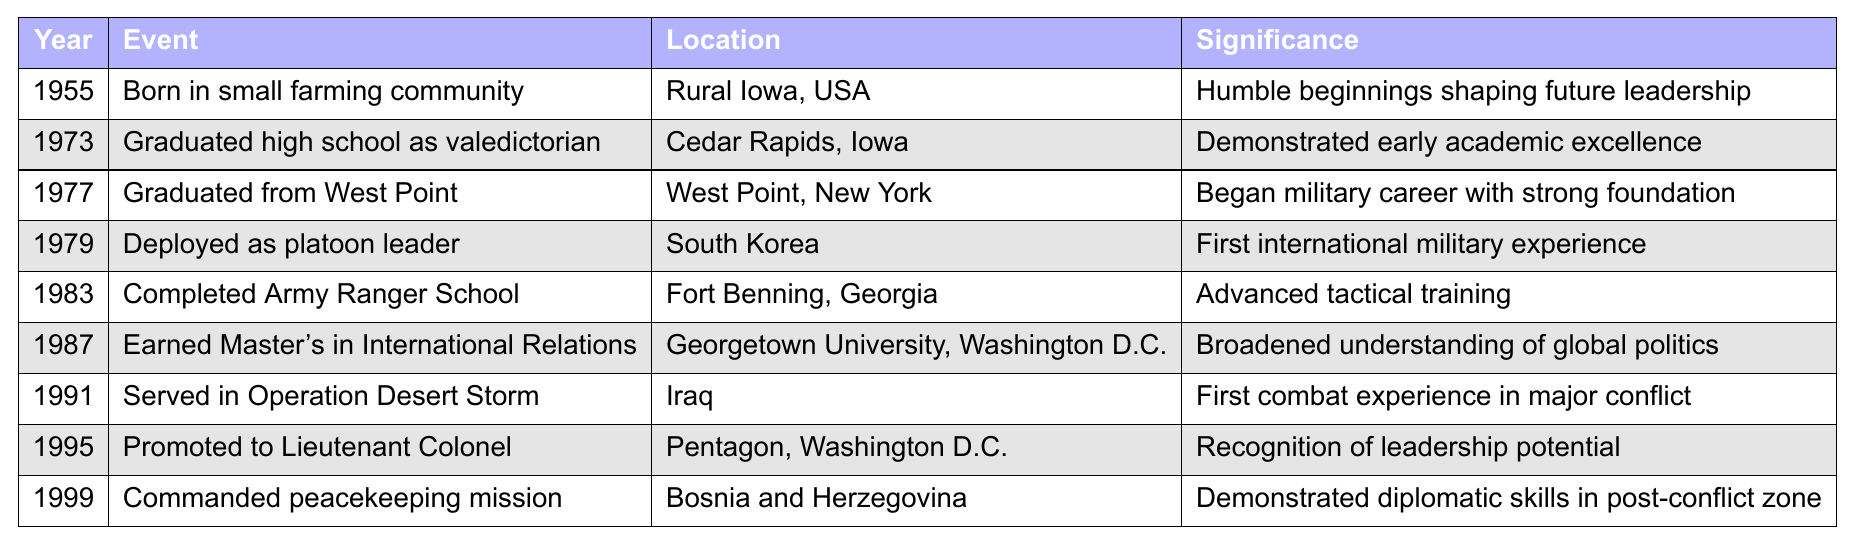What year was the general born? The table shows that the general was born in the year 1955.
Answer: 1955 What event took place in 1973? According to the table, the event listed for 1973 is "Graduated high school as valedictorian."
Answer: Graduated high school as valedictorian Where did the general complete Army Ranger School? The table indicates that Army Ranger School was completed at Fort Benning, Georgia.
Answer: Fort Benning, Georgia What is the significance of the year 1987? In 1987, the general earned a Master's in International Relations, which broadened his understanding of global politics.
Answer: Broadened understanding of global politics How many years elapsed between the general's graduation from West Point and his deployment as a platoon leader? The general graduated from West Point in 1977 and was deployed as a platoon leader in 1979. The difference is 2 years (1979 - 1977).
Answer: 2 years Did the general serve in combat before 1991? According to the table, there is no mention of combat before 1991; his first combat experience was during Operation Desert Storm in 1991.
Answer: No What was the general's first international military experience? From the table, the general's first international military experience was his deployment as a platoon leader in South Korea in 1979.
Answer: Deployed as platoon leader in South Korea Count the number of major educational milestones listed in the table. The table lists two major educational milestones: graduating high school in 1973 and earning a Master's degree in 1987. Thus, the count is 2.
Answer: 2 In which location did the general command a peacekeeping mission? The table specifies that the peacekeeping mission was commanded in Bosnia and Herzegovina in 1999.
Answer: Bosnia and Herzegovina What can be inferred about the general's academic performance in high school? The table notes that he graduated high school as valedictorian, suggesting he performed excellently academically.
Answer: Excellent academic performance List the events that led to the general being promoted to Lieutenant Colonel. The promotion to Lieutenant Colonel in 1995 followed his recognition for leadership potential, gained through earlier military service like Operation Desert Storm and commanding a peacekeeping mission.
Answer: Service and leadership potential What is the relationship between the general's early education and his military career? His early academic excellence as a valedictorian likely provided a strong foundation for his subsequent military career, including graduating from West Point.
Answer: Strong foundation for military career How many years after graduating from West Point did the general serve in Operation Desert Storm? The general graduated from West Point in 1977 and served in Operation Desert Storm in 1991, which is a difference of 14 years (1991 - 1977).
Answer: 14 years What role did the general hold during his first combat experience? The table describes his role during his first combat experience as part of Operation Desert Storm, although it does not specify a particular position within that operation.
Answer: Part of Operation Desert Storm In what manner did the general's education in International Relations influence his military career? The Master's in International Relations earned in 1987 is deemed significant for broadening his understanding of global politics, likely aiding in his subsequent peacekeeping mission.
Answer: Aided in understanding global politics for peacekeeping 